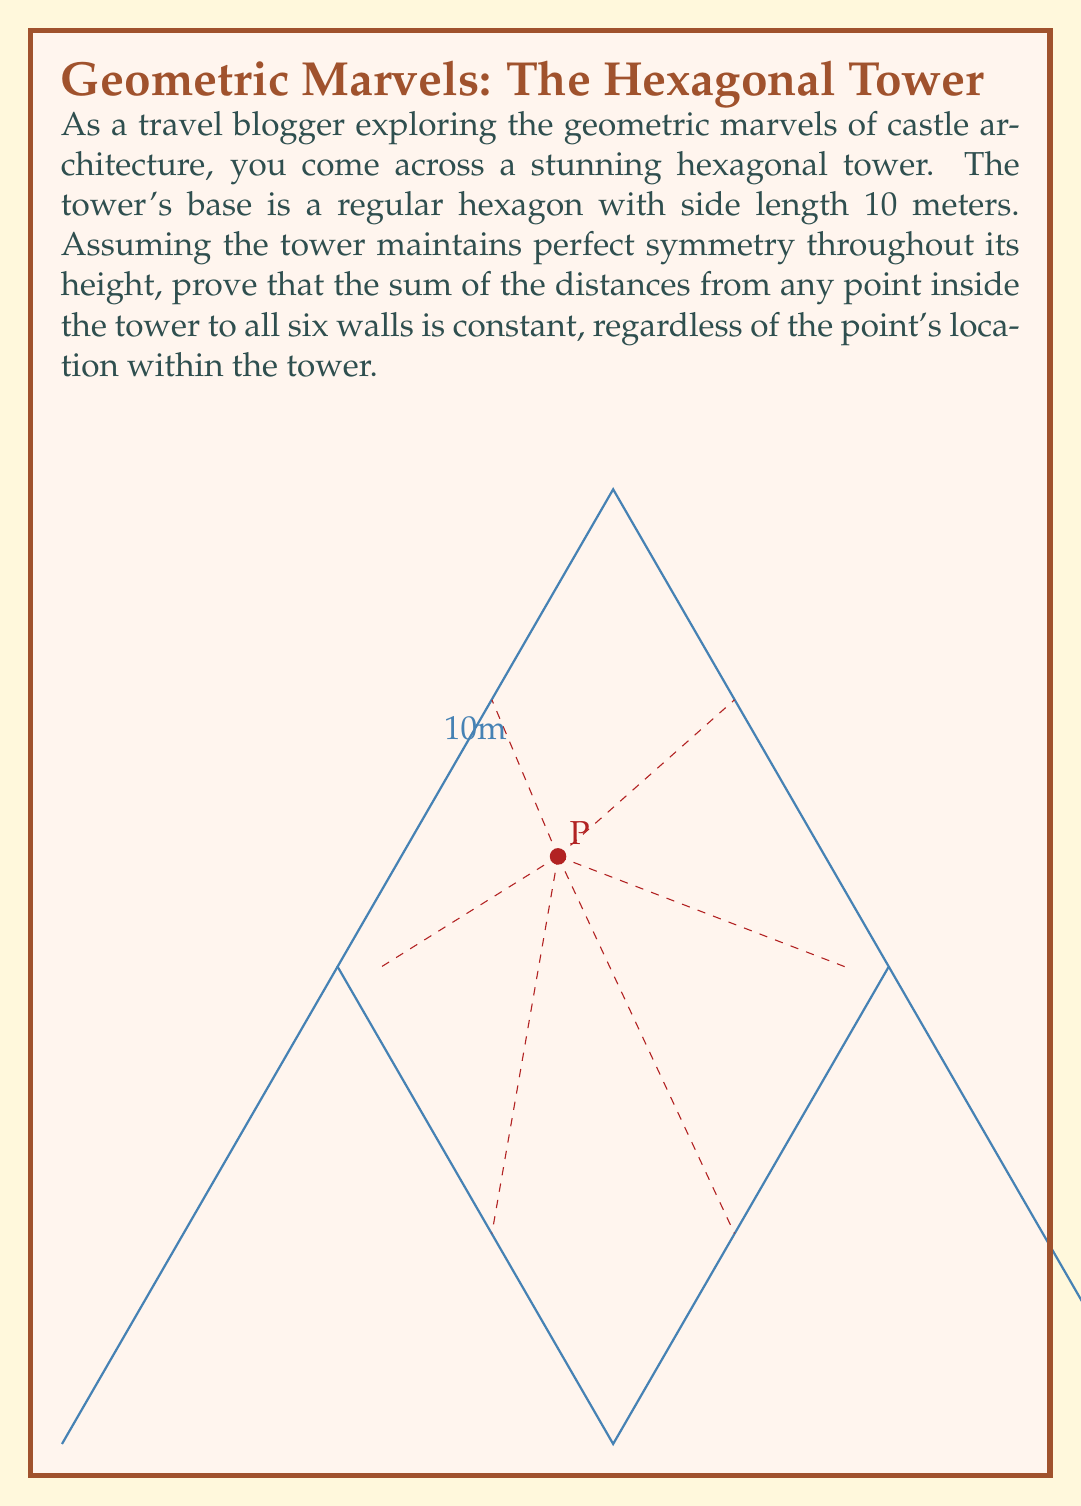Show me your answer to this math problem. Let's approach this proof step-by-step using the properties of regular hexagons and the concept of symmetry:

1) In a regular hexagon, the distance from the center to any side is constant. Let's call this distance $h$. We can calculate $h$ using the side length $s$:

   $$h = \frac{\sqrt{3}}{2}s = \frac{\sqrt{3}}{2} \cdot 10 = 5\sqrt{3}$$ meters

2) Let's consider an arbitrary point P inside the hexagon. We need to prove that the sum of distances from P to all six sides is constant.

3) Draw lines from P perpendicular to each side of the hexagon. These lines represent the shortest distances from P to each side.

4) Now, consider the triangle formed by the center of the hexagon (O), point P, and any vertex of the hexagon (V). This triangle can be divided into three smaller triangles by drawing lines from P to the two sides adjacent to V.

5) The areas of these three triangles sum up to the area of OVP:

   $$A_{OVP} = A_1 + A_2 + A_3$$

6) The area of OVP can be expressed as:

   $$A_{OVP} = \frac{1}{2} \cdot s \cdot h = \frac{1}{2} \cdot 10 \cdot 5\sqrt{3} = 25\sqrt{3}$$ square meters

7) The areas of the smaller triangles can be expressed using the distances from P to the sides ($d_1$, $d_2$, $d_3$):

   $$A_1 = \frac{1}{2} \cdot s \cdot d_1$$
   $$A_2 = \frac{1}{2} \cdot s \cdot d_2$$
   $$A_3 = \frac{1}{2} \cdot s \cdot d_3$$

8) Substituting these into the equation from step 5:

   $$25\sqrt{3} = \frac{1}{2} \cdot 10 \cdot (d_1 + d_2 + d_3)$$

9) Simplifying:

   $$5\sqrt{3} = d_1 + d_2 + d_3$$

10) This equation holds for each pair of adjacent sides. Since there are 6 sides in total, the sum of all distances is:

    $$d_1 + d_2 + d_3 + d_4 + d_5 + d_6 = 2 \cdot 5\sqrt{3} = 10\sqrt{3}$$

11) This sum is constant and independent of the location of P, which proves our statement.
Answer: $10\sqrt{3}$ meters 